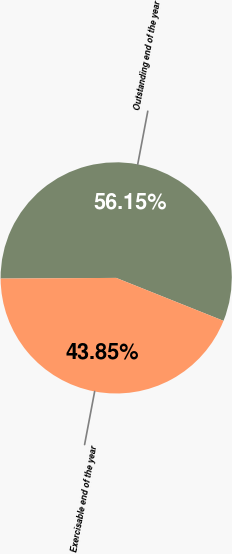Convert chart. <chart><loc_0><loc_0><loc_500><loc_500><pie_chart><fcel>Outstanding end of the year<fcel>Exercisable end of the year<nl><fcel>56.15%<fcel>43.85%<nl></chart> 